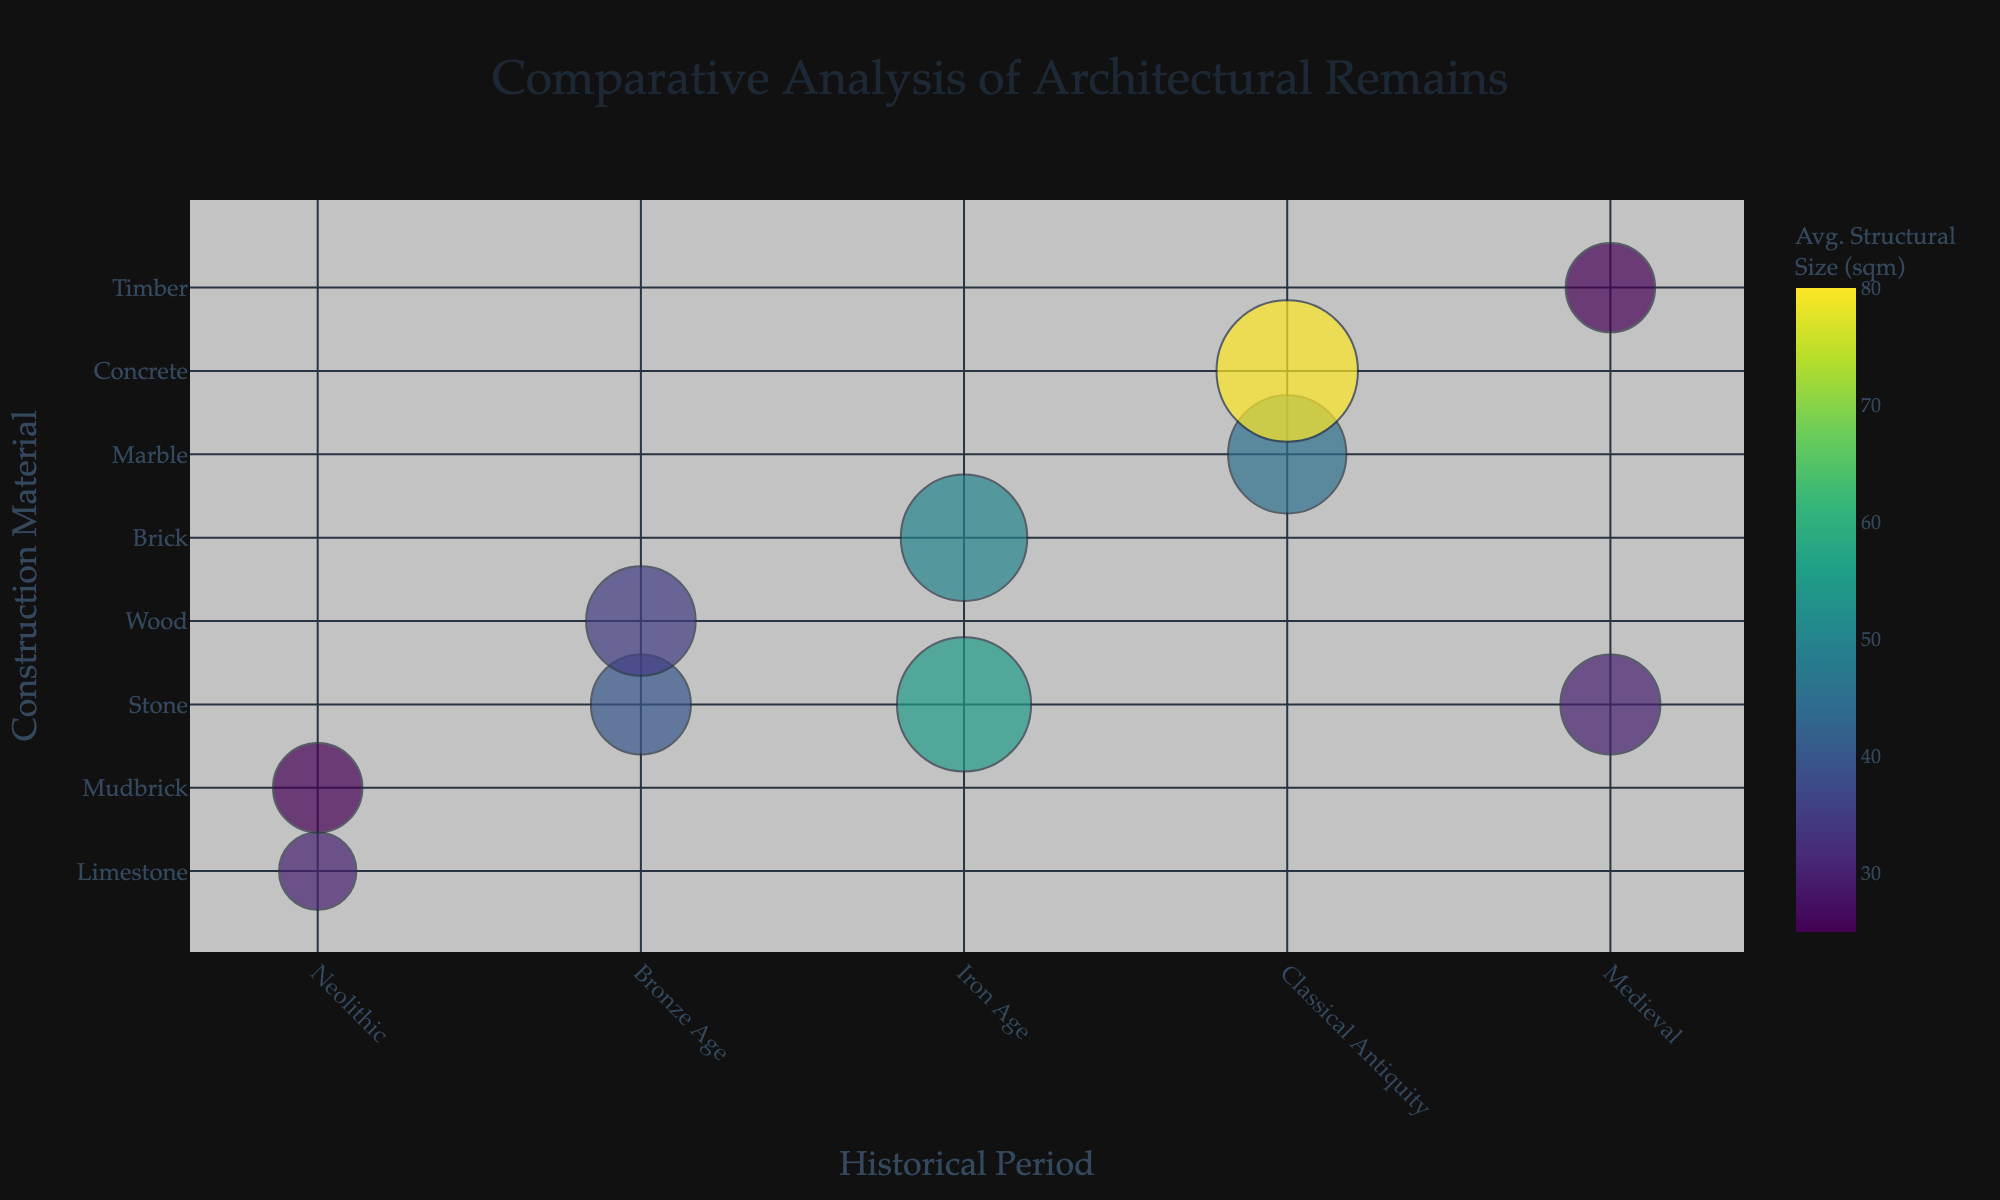What is the title of the bubble chart? The title is prominently displayed at the top center of the chart, set in large font and reads "Comparative Analysis of Architectural Remains".
Answer: Comparative Analysis of Architectural Remains Which material type has the largest bubble in the Iron Age? The size of the bubbles corresponds to the number of structures, and in the Iron Age, the largest bubble is for Brick, indicating Babylon.
Answer: Brick How many structures were discovered at Çatalhöyük? By hovering over the bubble representing Çatalhöyük (Neolithic period, Limestone material), the hover data shows 15 structures.
Answer: 15 Which period has the highest average structural size for Stone material? Comparing the average structural size of all bubbles related to Stone material, the Iron Age (Persepolis with 55 sqm) has the highest average structural size.
Answer: Iron Age What is the discovery count for the Colosseum? By hovering over the bubble representing the Colosseum (Classical Antiquity period, Concrete material), the hover data shows 250 discoveries.
Answer: 250 Compare the number of structures between Mycenae (Bronze Age, Stone) and Mont-Saint-Michel (Medieval, Stone). Which site has more structures? Mycenae has 25 structures, while Mont-Saint-Michel has 25 structures, so they have an equal number of structures.
Answer: Equal What is the color bar title in the chart? The color bar is labeled with the title "Avg. Structural Size (sqm)" indicating it represents the average structural size in square meters.
Answer: Avg. Structural Size (sqm) Which site from the Medieval period has the smallest average structural size? Among the bubbles from the Medieval period, Westminster Abbey (Timber material) has the smallest average structural size of 25 sqm.
Answer: Westminster Abbey What is the difference in average structural size between the Acropolis and the Colosseum? The Acropolis has an average structural size of 45 sqm, while the Colosseum has 80 sqm. The difference is calculated as 80 - 45 = 35 sqm.
Answer: 35 sqm How is size denoted in the bubble chart, and what does it represent? The size of each bubble denotes the number of structures, with larger bubbles representing a higher number of structures.
Answer: Number of structures 